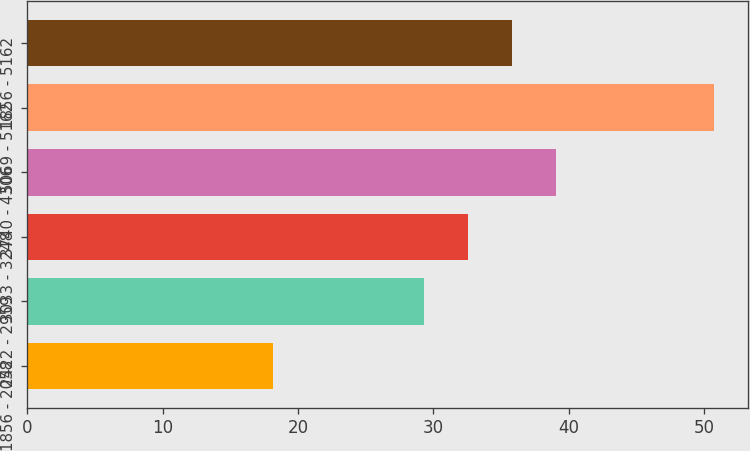<chart> <loc_0><loc_0><loc_500><loc_500><bar_chart><fcel>1856 - 2058<fcel>2422 - 2959<fcel>3033 - 3248<fcel>3740 - 4306<fcel>5069 - 5162<fcel>1856 - 5162<nl><fcel>18.17<fcel>29.31<fcel>32.56<fcel>39.06<fcel>50.7<fcel>35.81<nl></chart> 